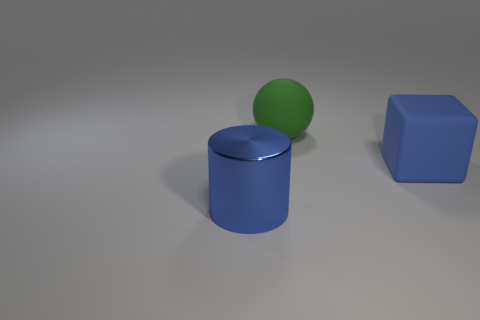Add 3 big metallic cylinders. How many objects exist? 6 Subtract all cylinders. How many objects are left? 2 Add 2 big blue metallic things. How many big blue metallic things are left? 3 Add 2 big blue metal things. How many big blue metal things exist? 3 Subtract 0 blue balls. How many objects are left? 3 Subtract all small yellow matte cubes. Subtract all large green balls. How many objects are left? 2 